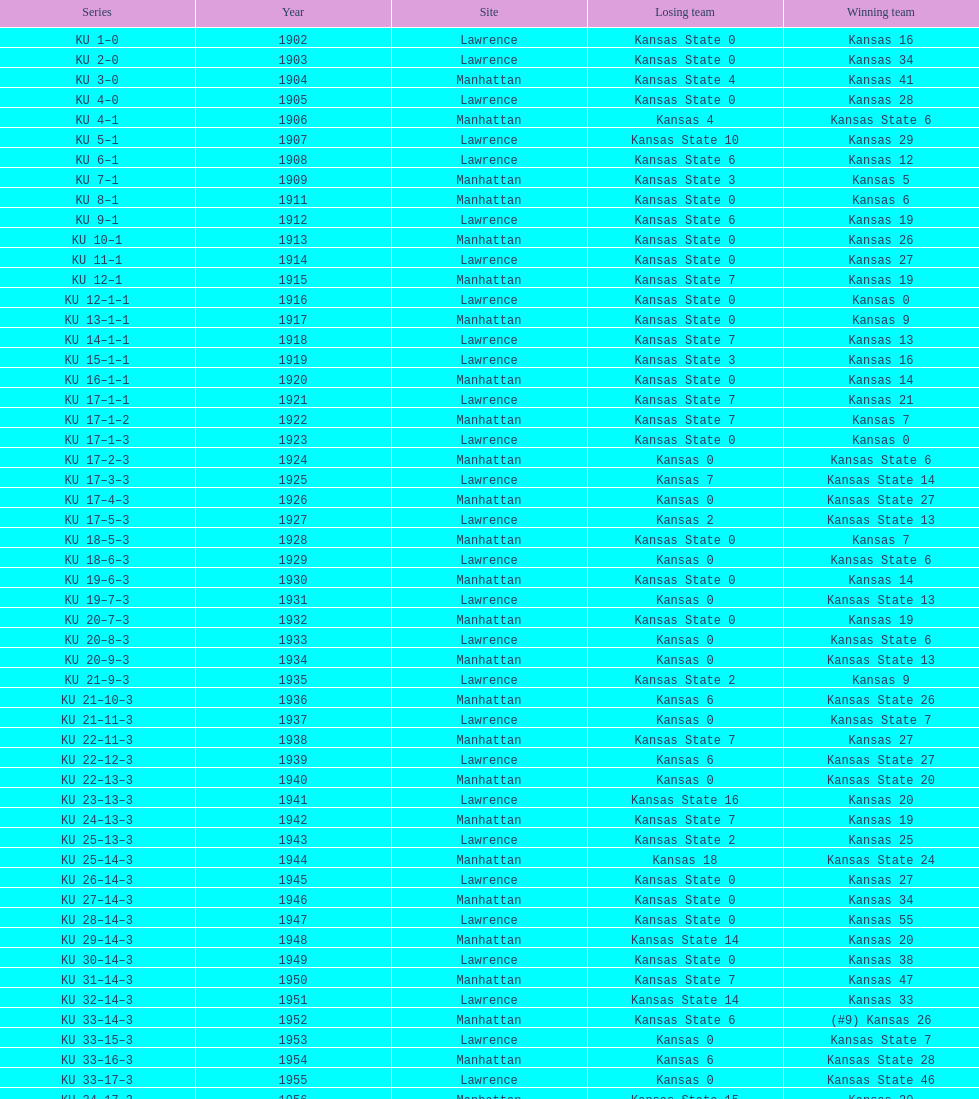When was the first game that kansas state won by double digits? 1926. 